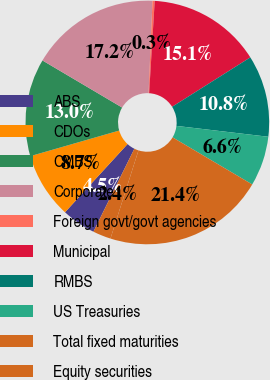Convert chart. <chart><loc_0><loc_0><loc_500><loc_500><pie_chart><fcel>ABS<fcel>CDOs<fcel>CMBS<fcel>Corporate<fcel>Foreign govt/govt agencies<fcel>Municipal<fcel>RMBS<fcel>US Treasuries<fcel>Total fixed maturities<fcel>Equity securities<nl><fcel>4.51%<fcel>8.73%<fcel>12.95%<fcel>17.17%<fcel>0.29%<fcel>15.06%<fcel>10.84%<fcel>6.62%<fcel>21.39%<fcel>2.4%<nl></chart> 